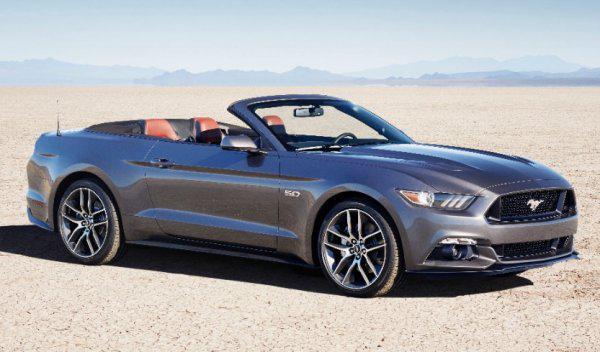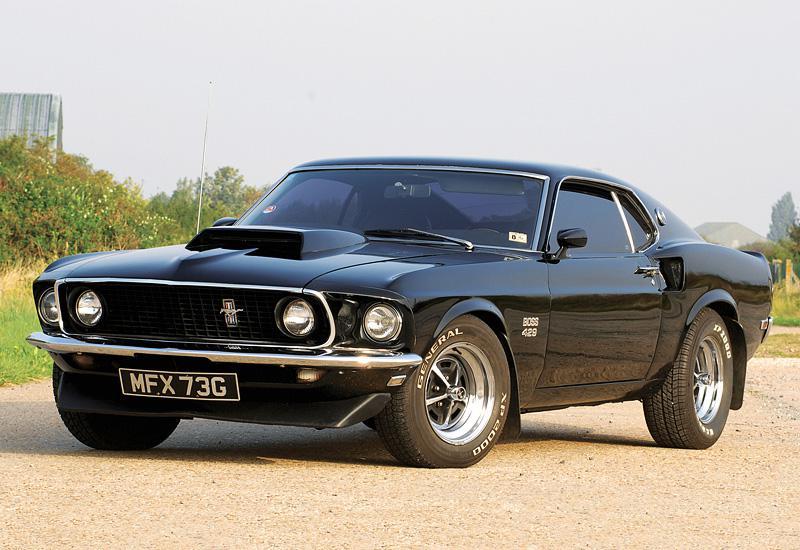The first image is the image on the left, the second image is the image on the right. Considering the images on both sides, is "There is a red convertible car in one image" valid? Answer yes or no. No. The first image is the image on the left, the second image is the image on the right. Considering the images on both sides, is "There is a red convertible in one image." valid? Answer yes or no. No. 